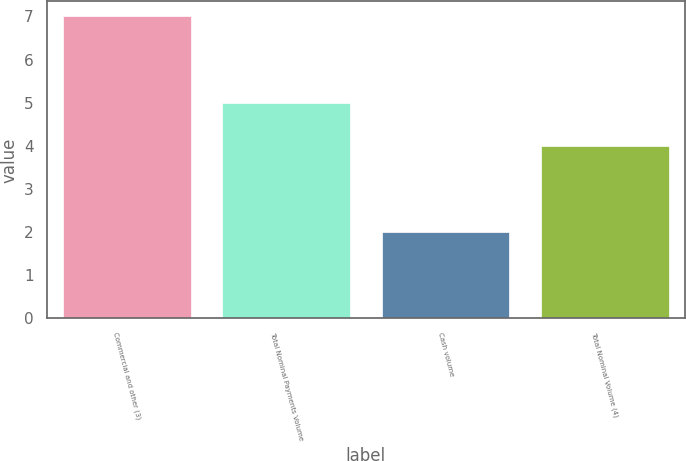Convert chart to OTSL. <chart><loc_0><loc_0><loc_500><loc_500><bar_chart><fcel>Commercial and other (3)<fcel>Total Nominal Payments Volume<fcel>Cash volume<fcel>Total Nominal Volume (4)<nl><fcel>7<fcel>5<fcel>2<fcel>4<nl></chart> 